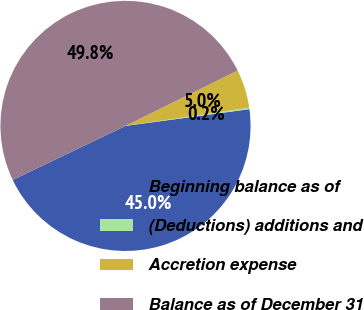Convert chart to OTSL. <chart><loc_0><loc_0><loc_500><loc_500><pie_chart><fcel>Beginning balance as of<fcel>(Deductions) additions and<fcel>Accretion expense<fcel>Balance as of December 31<nl><fcel>45.03%<fcel>0.19%<fcel>4.97%<fcel>49.81%<nl></chart> 